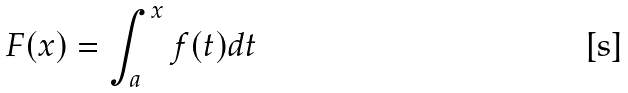Convert formula to latex. <formula><loc_0><loc_0><loc_500><loc_500>F ( x ) = \int _ { a } ^ { x } f ( t ) d t</formula> 